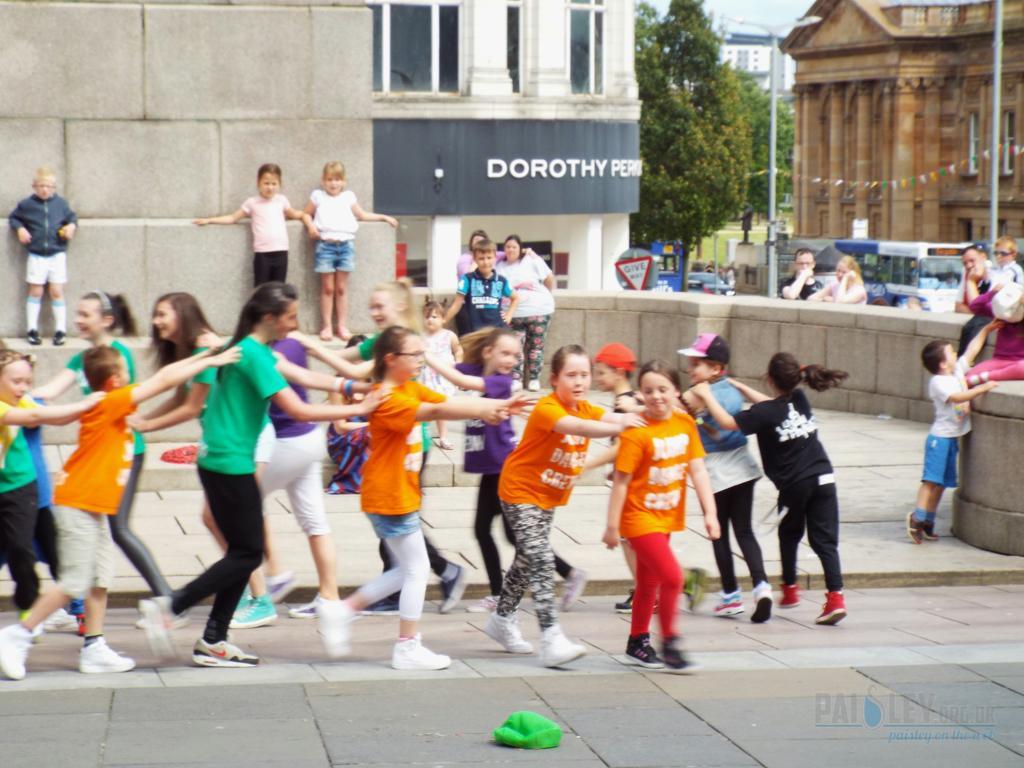In one or two sentences, can you explain what this image depicts? In the picture I can see these people are walking on the road, here we can see a green color object placed on the road. In the background, we can see a few more children standing near the wall, we can see boards, vehicles moving on the road, we can see buildings, trees, light poles and the sky. Here we can see the watermark on the bottom right side of the image. 